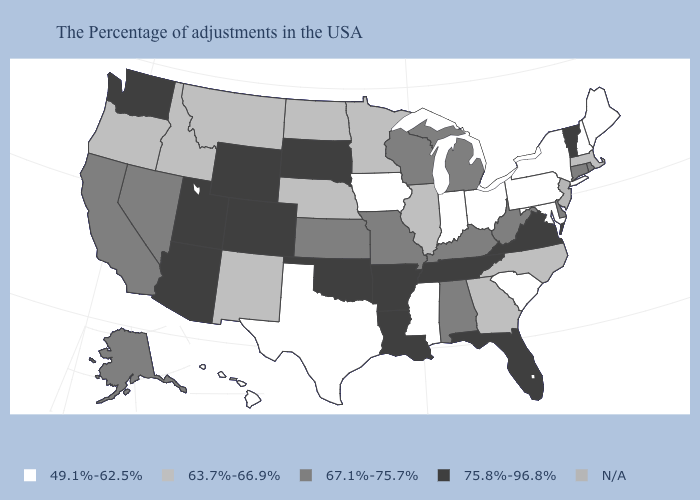Name the states that have a value in the range N/A?
Be succinct. New Jersey. Name the states that have a value in the range 63.7%-66.9%?
Keep it brief. Massachusetts, North Carolina, Georgia, Illinois, Minnesota, Nebraska, North Dakota, New Mexico, Montana, Idaho, Oregon. Which states have the lowest value in the USA?
Concise answer only. Maine, New Hampshire, New York, Maryland, Pennsylvania, South Carolina, Ohio, Indiana, Mississippi, Iowa, Texas, Hawaii. Does the map have missing data?
Be succinct. Yes. Name the states that have a value in the range 75.8%-96.8%?
Concise answer only. Vermont, Virginia, Florida, Tennessee, Louisiana, Arkansas, Oklahoma, South Dakota, Wyoming, Colorado, Utah, Arizona, Washington. What is the value of Ohio?
Short answer required. 49.1%-62.5%. Among the states that border New Hampshire , which have the lowest value?
Be succinct. Maine. Name the states that have a value in the range 63.7%-66.9%?
Give a very brief answer. Massachusetts, North Carolina, Georgia, Illinois, Minnesota, Nebraska, North Dakota, New Mexico, Montana, Idaho, Oregon. Name the states that have a value in the range 67.1%-75.7%?
Be succinct. Rhode Island, Connecticut, Delaware, West Virginia, Michigan, Kentucky, Alabama, Wisconsin, Missouri, Kansas, Nevada, California, Alaska. Which states hav the highest value in the MidWest?
Short answer required. South Dakota. Does North Carolina have the lowest value in the South?
Be succinct. No. How many symbols are there in the legend?
Short answer required. 5. What is the value of South Dakota?
Short answer required. 75.8%-96.8%. Is the legend a continuous bar?
Concise answer only. No. 